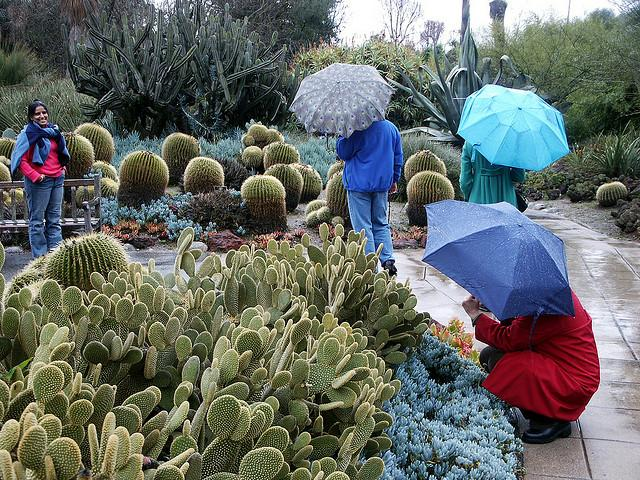These types of plants are good in what environment? Please explain your reasoning. desert. This is cactus which needs a lot of sun and little water 